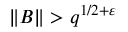<formula> <loc_0><loc_0><loc_500><loc_500>\| B \| > q ^ { 1 / 2 + \varepsilon }</formula> 